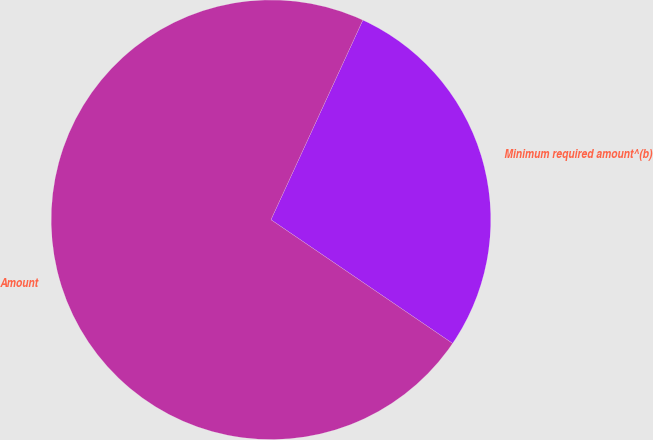Convert chart to OTSL. <chart><loc_0><loc_0><loc_500><loc_500><pie_chart><fcel>Minimum required amount^(b)<fcel>Amount<nl><fcel>27.65%<fcel>72.35%<nl></chart> 